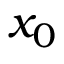<formula> <loc_0><loc_0><loc_500><loc_500>x _ { 0 }</formula> 